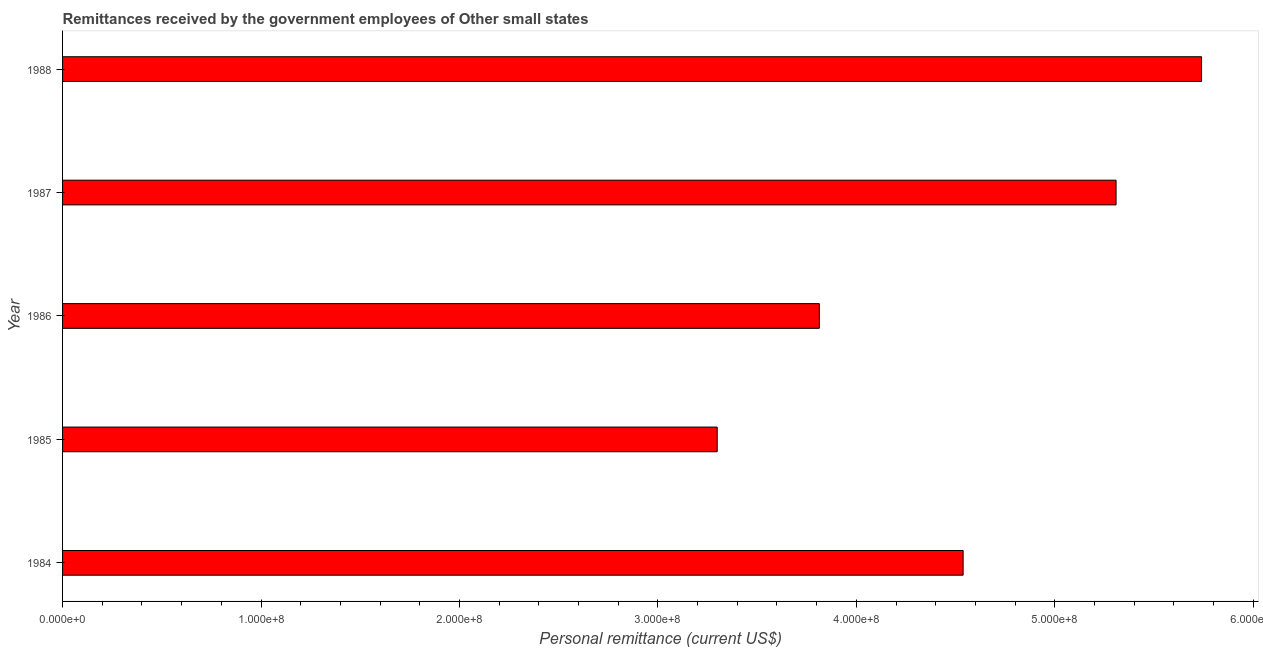Does the graph contain grids?
Provide a short and direct response. No. What is the title of the graph?
Your answer should be very brief. Remittances received by the government employees of Other small states. What is the label or title of the X-axis?
Give a very brief answer. Personal remittance (current US$). What is the label or title of the Y-axis?
Offer a very short reply. Year. What is the personal remittances in 1988?
Provide a short and direct response. 5.74e+08. Across all years, what is the maximum personal remittances?
Keep it short and to the point. 5.74e+08. Across all years, what is the minimum personal remittances?
Offer a very short reply. 3.30e+08. In which year was the personal remittances maximum?
Offer a very short reply. 1988. In which year was the personal remittances minimum?
Give a very brief answer. 1985. What is the sum of the personal remittances?
Ensure brevity in your answer.  2.27e+09. What is the difference between the personal remittances in 1984 and 1986?
Keep it short and to the point. 7.25e+07. What is the average personal remittances per year?
Ensure brevity in your answer.  4.54e+08. What is the median personal remittances?
Ensure brevity in your answer.  4.54e+08. In how many years, is the personal remittances greater than 240000000 US$?
Your response must be concise. 5. Do a majority of the years between 1987 and 1988 (inclusive) have personal remittances greater than 80000000 US$?
Ensure brevity in your answer.  Yes. What is the ratio of the personal remittances in 1984 to that in 1987?
Offer a terse response. 0.85. Is the personal remittances in 1987 less than that in 1988?
Provide a succinct answer. Yes. Is the difference between the personal remittances in 1985 and 1987 greater than the difference between any two years?
Your response must be concise. No. What is the difference between the highest and the second highest personal remittances?
Ensure brevity in your answer.  4.31e+07. Is the sum of the personal remittances in 1985 and 1986 greater than the maximum personal remittances across all years?
Offer a terse response. Yes. What is the difference between the highest and the lowest personal remittances?
Offer a terse response. 2.44e+08. In how many years, is the personal remittances greater than the average personal remittances taken over all years?
Your response must be concise. 2. How many bars are there?
Keep it short and to the point. 5. How many years are there in the graph?
Your answer should be compact. 5. Are the values on the major ticks of X-axis written in scientific E-notation?
Provide a short and direct response. Yes. What is the Personal remittance (current US$) in 1984?
Offer a very short reply. 4.54e+08. What is the Personal remittance (current US$) of 1985?
Your answer should be compact. 3.30e+08. What is the Personal remittance (current US$) of 1986?
Keep it short and to the point. 3.81e+08. What is the Personal remittance (current US$) in 1987?
Offer a very short reply. 5.31e+08. What is the Personal remittance (current US$) of 1988?
Your answer should be very brief. 5.74e+08. What is the difference between the Personal remittance (current US$) in 1984 and 1985?
Offer a very short reply. 1.24e+08. What is the difference between the Personal remittance (current US$) in 1984 and 1986?
Make the answer very short. 7.25e+07. What is the difference between the Personal remittance (current US$) in 1984 and 1987?
Your response must be concise. -7.71e+07. What is the difference between the Personal remittance (current US$) in 1984 and 1988?
Provide a short and direct response. -1.20e+08. What is the difference between the Personal remittance (current US$) in 1985 and 1986?
Keep it short and to the point. -5.15e+07. What is the difference between the Personal remittance (current US$) in 1985 and 1987?
Offer a very short reply. -2.01e+08. What is the difference between the Personal remittance (current US$) in 1985 and 1988?
Your response must be concise. -2.44e+08. What is the difference between the Personal remittance (current US$) in 1986 and 1987?
Keep it short and to the point. -1.50e+08. What is the difference between the Personal remittance (current US$) in 1986 and 1988?
Make the answer very short. -1.93e+08. What is the difference between the Personal remittance (current US$) in 1987 and 1988?
Provide a succinct answer. -4.31e+07. What is the ratio of the Personal remittance (current US$) in 1984 to that in 1985?
Your answer should be very brief. 1.38. What is the ratio of the Personal remittance (current US$) in 1984 to that in 1986?
Provide a short and direct response. 1.19. What is the ratio of the Personal remittance (current US$) in 1984 to that in 1987?
Provide a short and direct response. 0.85. What is the ratio of the Personal remittance (current US$) in 1984 to that in 1988?
Make the answer very short. 0.79. What is the ratio of the Personal remittance (current US$) in 1985 to that in 1986?
Offer a very short reply. 0.86. What is the ratio of the Personal remittance (current US$) in 1985 to that in 1987?
Give a very brief answer. 0.62. What is the ratio of the Personal remittance (current US$) in 1985 to that in 1988?
Give a very brief answer. 0.57. What is the ratio of the Personal remittance (current US$) in 1986 to that in 1987?
Your response must be concise. 0.72. What is the ratio of the Personal remittance (current US$) in 1986 to that in 1988?
Provide a short and direct response. 0.66. What is the ratio of the Personal remittance (current US$) in 1987 to that in 1988?
Your response must be concise. 0.93. 